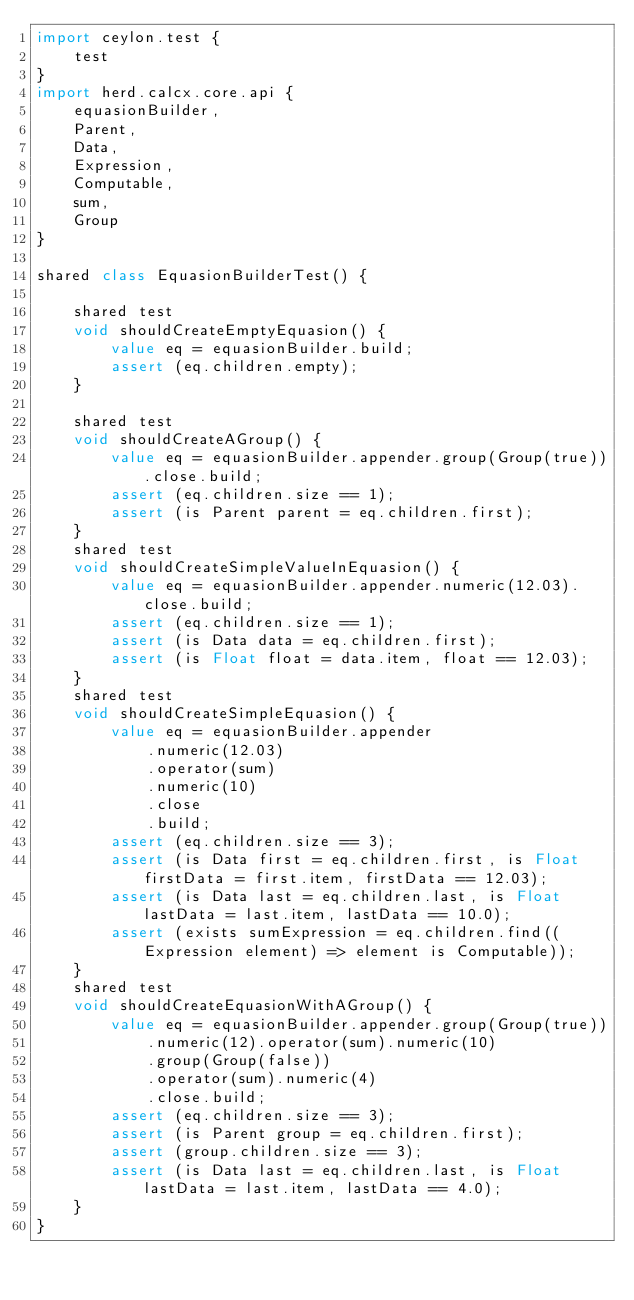Convert code to text. <code><loc_0><loc_0><loc_500><loc_500><_Ceylon_>import ceylon.test {
	test
}
import herd.calcx.core.api {
	equasionBuilder,
	Parent,
	Data,
	Expression,
	Computable,
	sum,
	Group
}

shared class EquasionBuilderTest() {
	
	shared test
	void shouldCreateEmptyEquasion() {
		value eq = equasionBuilder.build;
		assert (eq.children.empty);
	}
	
	shared test
	void shouldCreateAGroup() {
		value eq = equasionBuilder.appender.group(Group(true)).close.build;
		assert (eq.children.size == 1);
		assert (is Parent parent = eq.children.first);
	}
	shared test
	void shouldCreateSimpleValueInEquasion() {
		value eq = equasionBuilder.appender.numeric(12.03).close.build;
		assert (eq.children.size == 1);
		assert (is Data data = eq.children.first);
		assert (is Float float = data.item, float == 12.03);
	}
	shared test
	void shouldCreateSimpleEquasion() {
		value eq = equasionBuilder.appender
			.numeric(12.03)
			.operator(sum)
			.numeric(10)
			.close
			.build;
		assert (eq.children.size == 3);
		assert (is Data first = eq.children.first, is Float firstData = first.item, firstData == 12.03);
		assert (is Data last = eq.children.last, is Float lastData = last.item, lastData == 10.0);
		assert (exists sumExpression = eq.children.find((Expression element) => element is Computable));
	}
	shared test
	void shouldCreateEquasionWithAGroup() {
		value eq = equasionBuilder.appender.group(Group(true))
			.numeric(12).operator(sum).numeric(10)
			.group(Group(false))
			.operator(sum).numeric(4)
			.close.build;
		assert (eq.children.size == 3);
		assert (is Parent group = eq.children.first);
		assert (group.children.size == 3);
		assert (is Data last = eq.children.last, is Float lastData = last.item, lastData == 4.0);
	}
}
</code> 